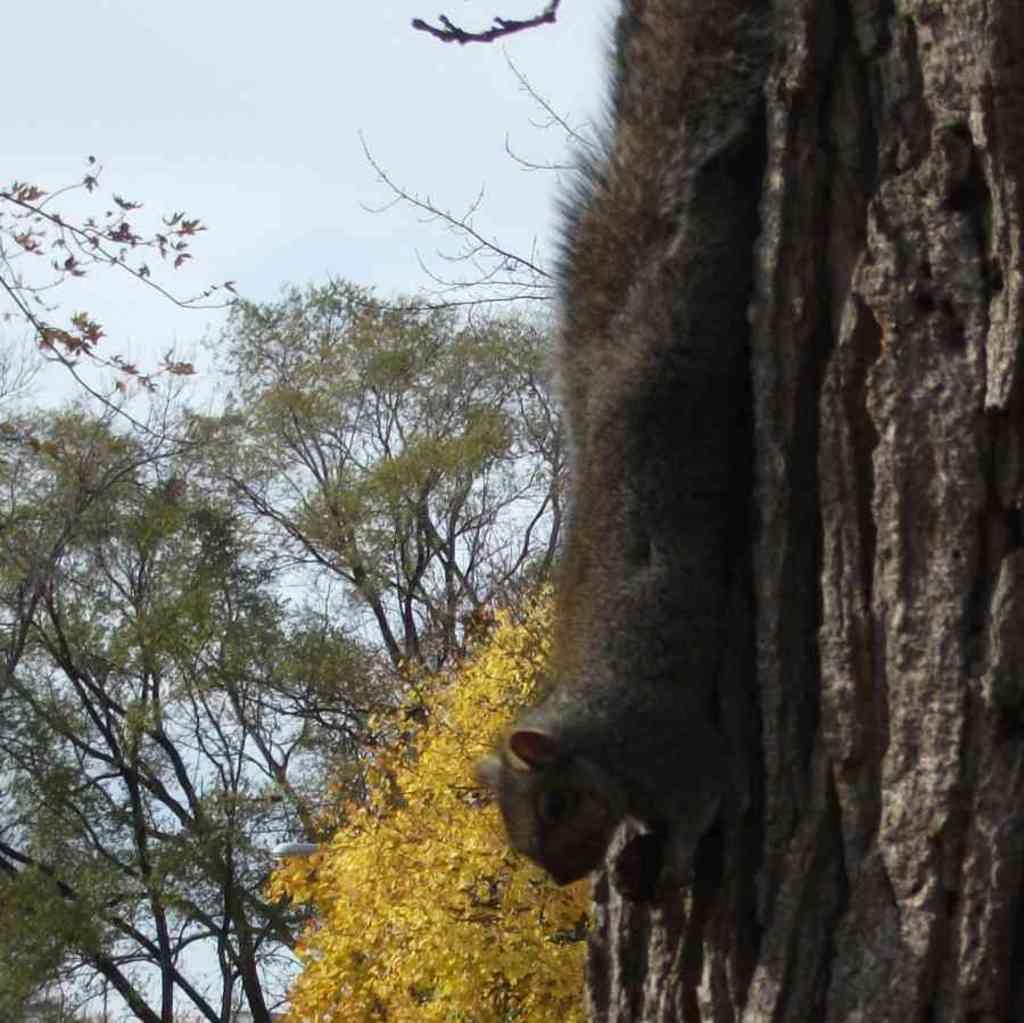Describe this image in one or two sentences. In this image we can see an animal on the wood, there are some trees and in the background we can see the sky. 